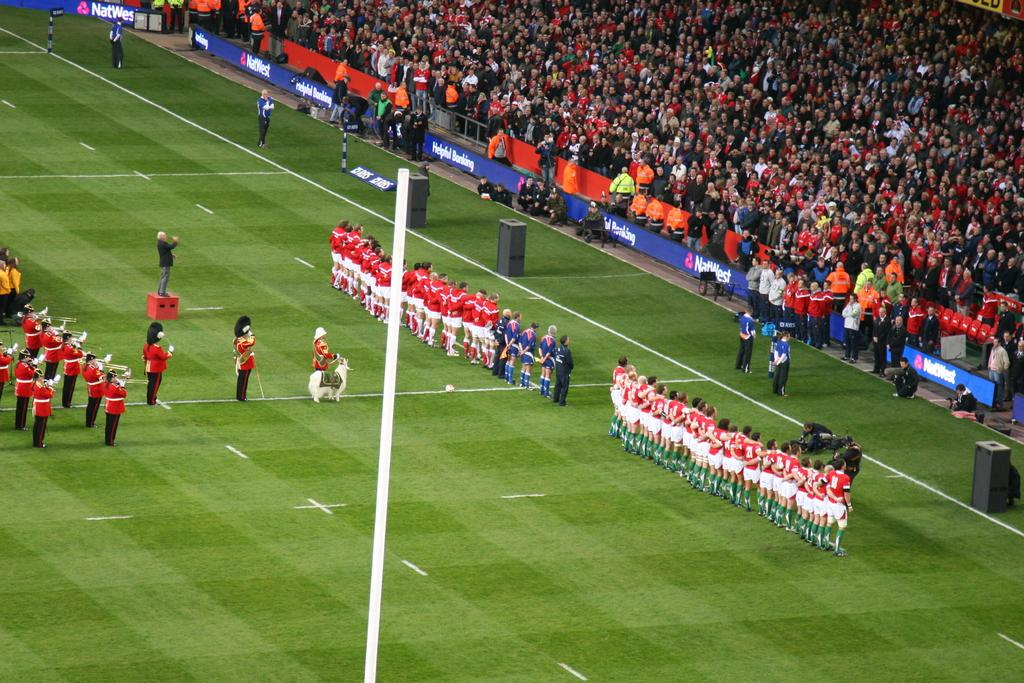What is the main setting of the image? The main setting of the image is a grassland. What type of activity might be taking place on the grassland? The grassland appears to be a football field, so a football game or practice might be taking place. Who are the people standing behind the fence in the image? The people standing behind the fence are audience members. What type of learning material can be seen in the image? There is no learning material present in the image; it features a grassland with people standing on it and audience members behind a fence. 